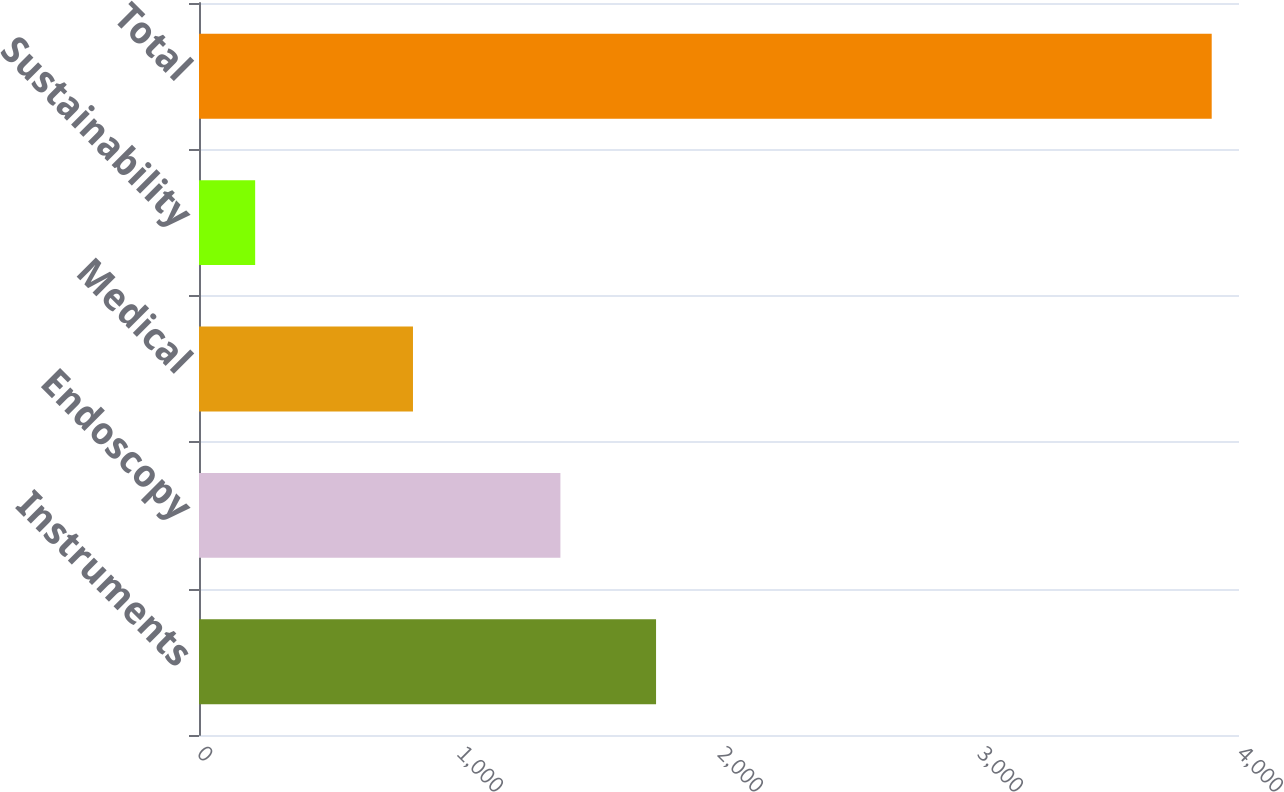Convert chart to OTSL. <chart><loc_0><loc_0><loc_500><loc_500><bar_chart><fcel>Instruments<fcel>Endoscopy<fcel>Medical<fcel>Sustainability<fcel>Total<nl><fcel>1757.9<fcel>1390<fcel>823<fcel>216<fcel>3895<nl></chart> 